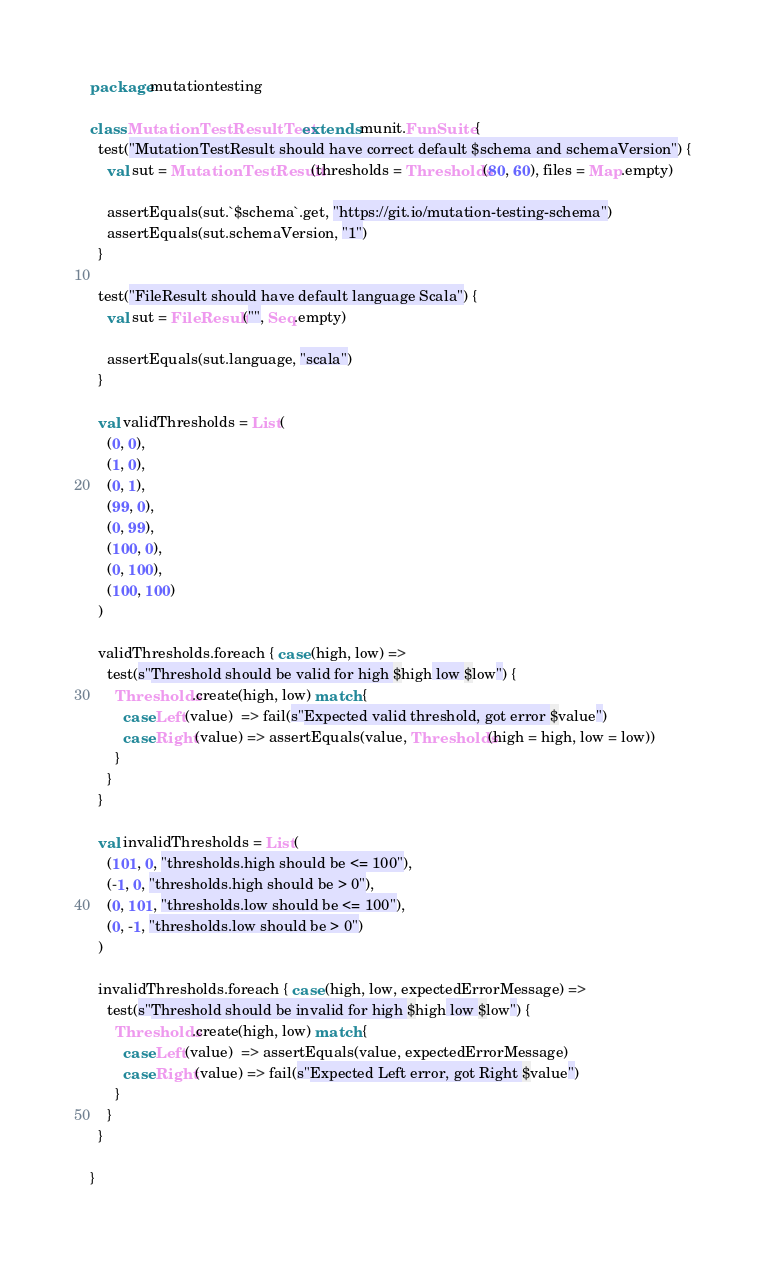Convert code to text. <code><loc_0><loc_0><loc_500><loc_500><_Scala_>package mutationtesting

class MutationTestResultTest extends munit.FunSuite {
  test("MutationTestResult should have correct default $schema and schemaVersion") {
    val sut = MutationTestResult(thresholds = Thresholds(80, 60), files = Map.empty)

    assertEquals(sut.`$schema`.get, "https://git.io/mutation-testing-schema")
    assertEquals(sut.schemaVersion, "1")
  }

  test("FileResult should have default language Scala") {
    val sut = FileResult("", Seq.empty)

    assertEquals(sut.language, "scala")
  }

  val validThresholds = List(
    (0, 0),
    (1, 0),
    (0, 1),
    (99, 0),
    (0, 99),
    (100, 0),
    (0, 100),
    (100, 100)
  )

  validThresholds.foreach { case (high, low) =>
    test(s"Threshold should be valid for high $high low $low") {
      Thresholds.create(high, low) match {
        case Left(value)  => fail(s"Expected valid threshold, got error $value")
        case Right(value) => assertEquals(value, Thresholds(high = high, low = low))
      }
    }
  }

  val invalidThresholds = List(
    (101, 0, "thresholds.high should be <= 100"),
    (-1, 0, "thresholds.high should be > 0"),
    (0, 101, "thresholds.low should be <= 100"),
    (0, -1, "thresholds.low should be > 0")
  )

  invalidThresholds.foreach { case (high, low, expectedErrorMessage) =>
    test(s"Threshold should be invalid for high $high low $low") {
      Thresholds.create(high, low) match {
        case Left(value)  => assertEquals(value, expectedErrorMessage)
        case Right(value) => fail(s"Expected Left error, got Right $value")
      }
    }
  }

}
</code> 